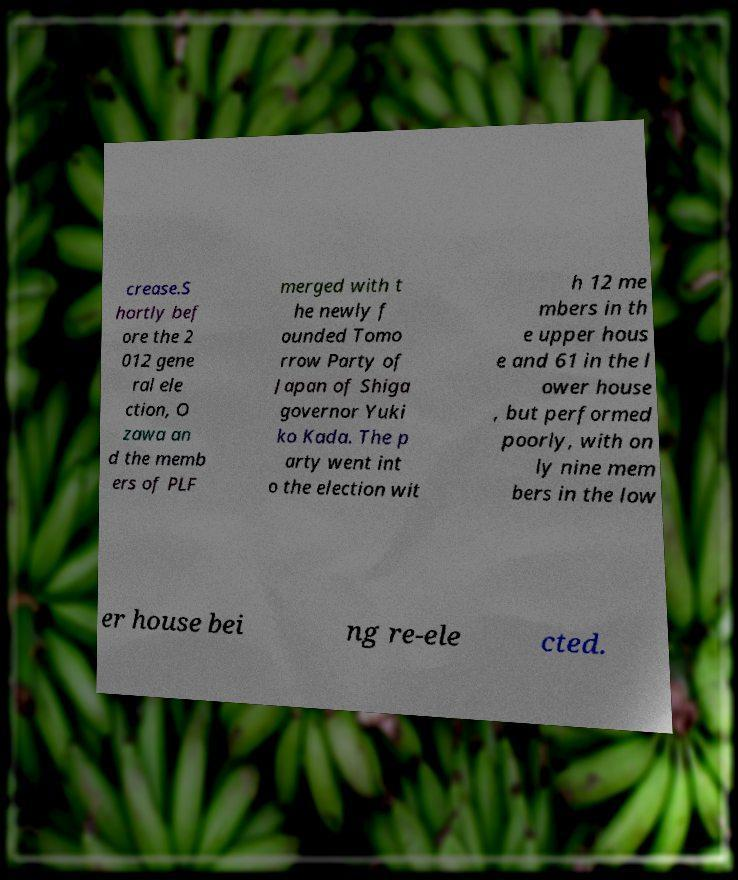Can you accurately transcribe the text from the provided image for me? crease.S hortly bef ore the 2 012 gene ral ele ction, O zawa an d the memb ers of PLF merged with t he newly f ounded Tomo rrow Party of Japan of Shiga governor Yuki ko Kada. The p arty went int o the election wit h 12 me mbers in th e upper hous e and 61 in the l ower house , but performed poorly, with on ly nine mem bers in the low er house bei ng re-ele cted. 